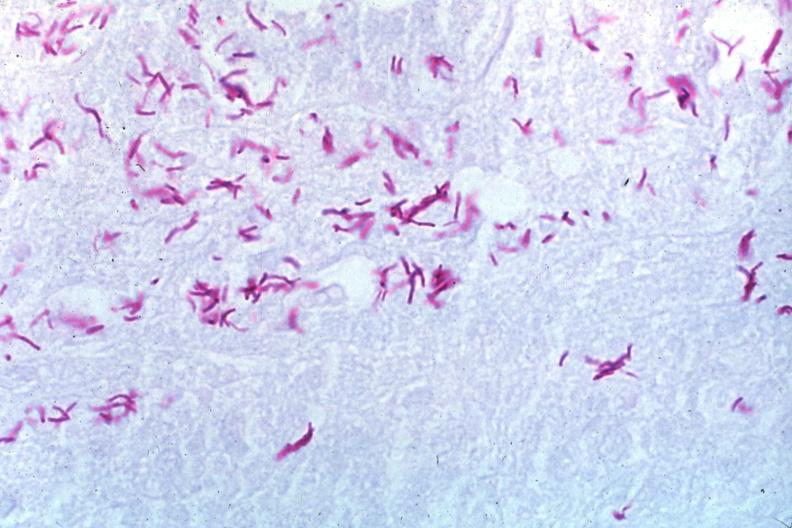s cervix duplication present?
Answer the question using a single word or phrase. No 